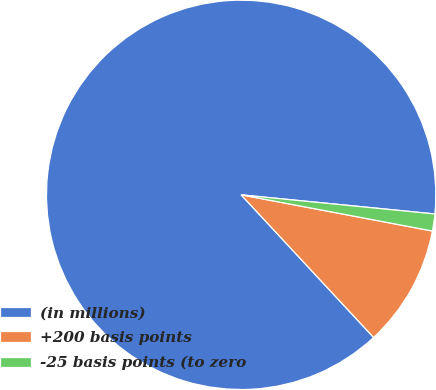Convert chart. <chart><loc_0><loc_0><loc_500><loc_500><pie_chart><fcel>(in millions)<fcel>+200 basis points<fcel>-25 basis points (to zero<nl><fcel>88.48%<fcel>10.11%<fcel>1.41%<nl></chart> 